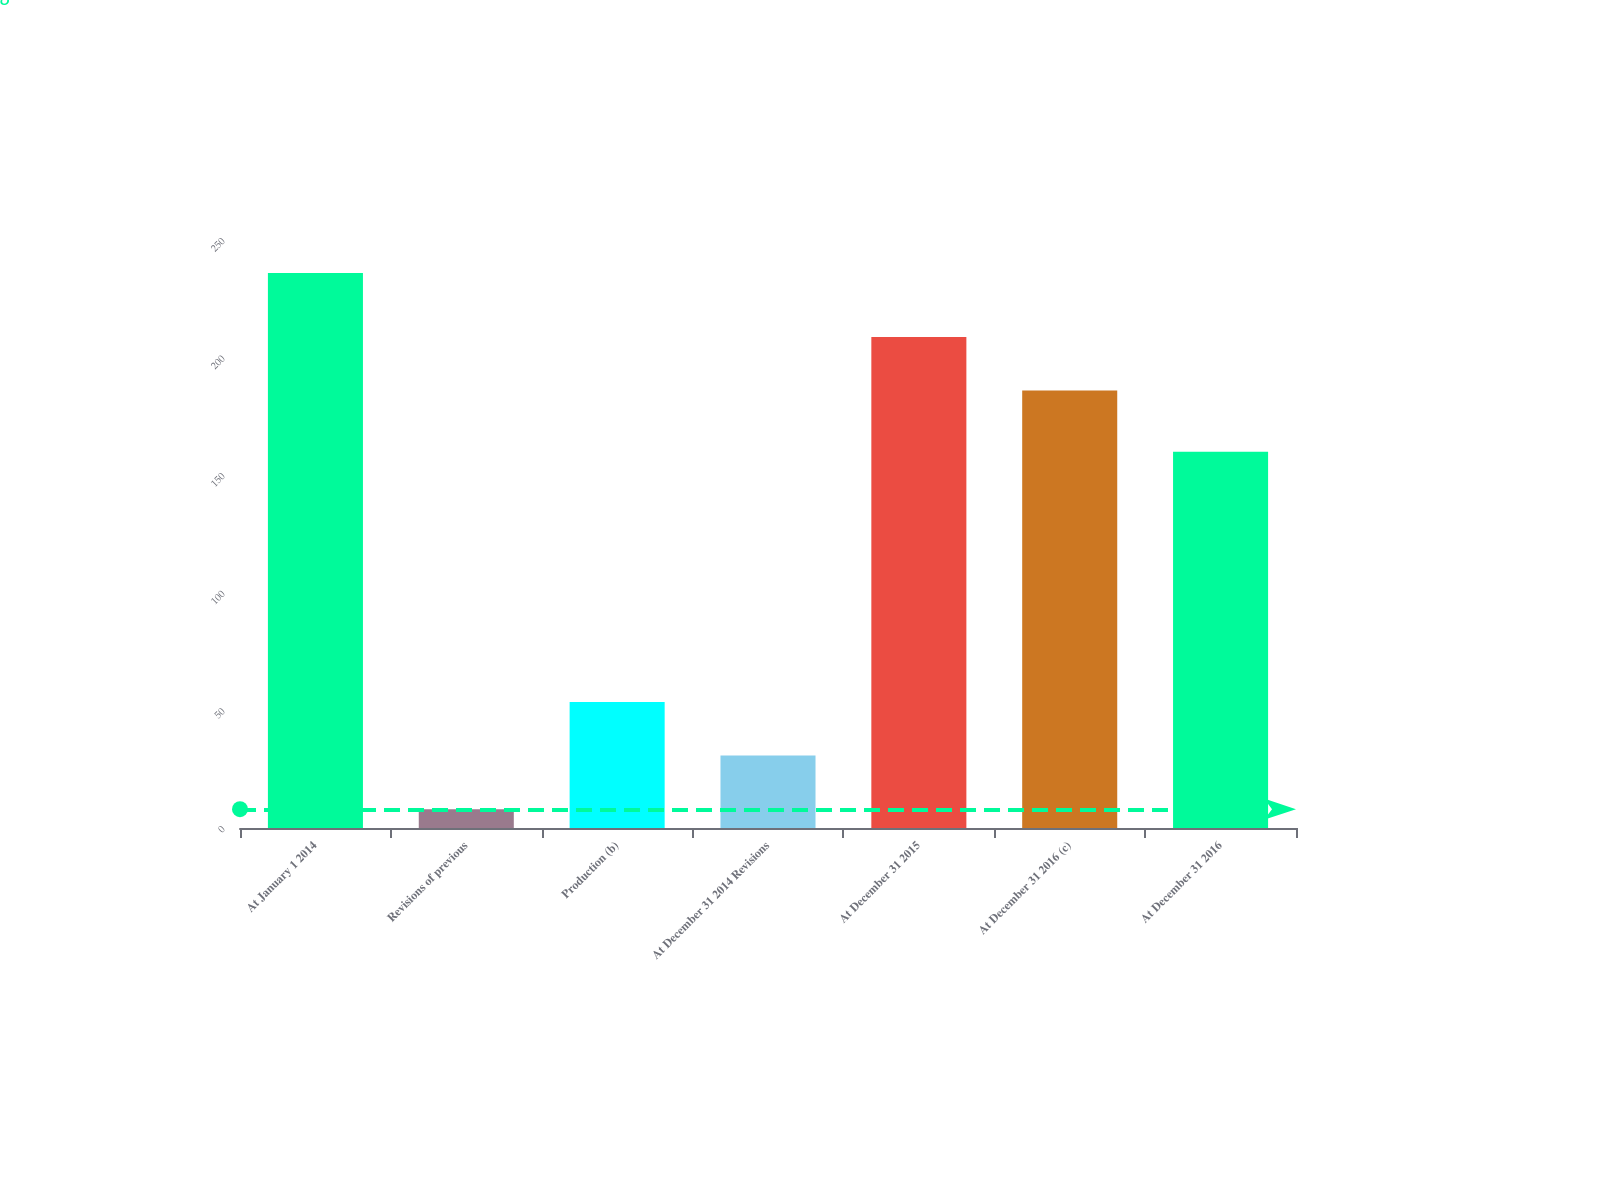Convert chart. <chart><loc_0><loc_0><loc_500><loc_500><bar_chart><fcel>At January 1 2014<fcel>Revisions of previous<fcel>Production (b)<fcel>At December 31 2014 Revisions<fcel>At December 31 2015<fcel>At December 31 2016 (c)<fcel>At December 31 2016<nl><fcel>236<fcel>8<fcel>53.6<fcel>30.8<fcel>208.8<fcel>186<fcel>160<nl></chart> 